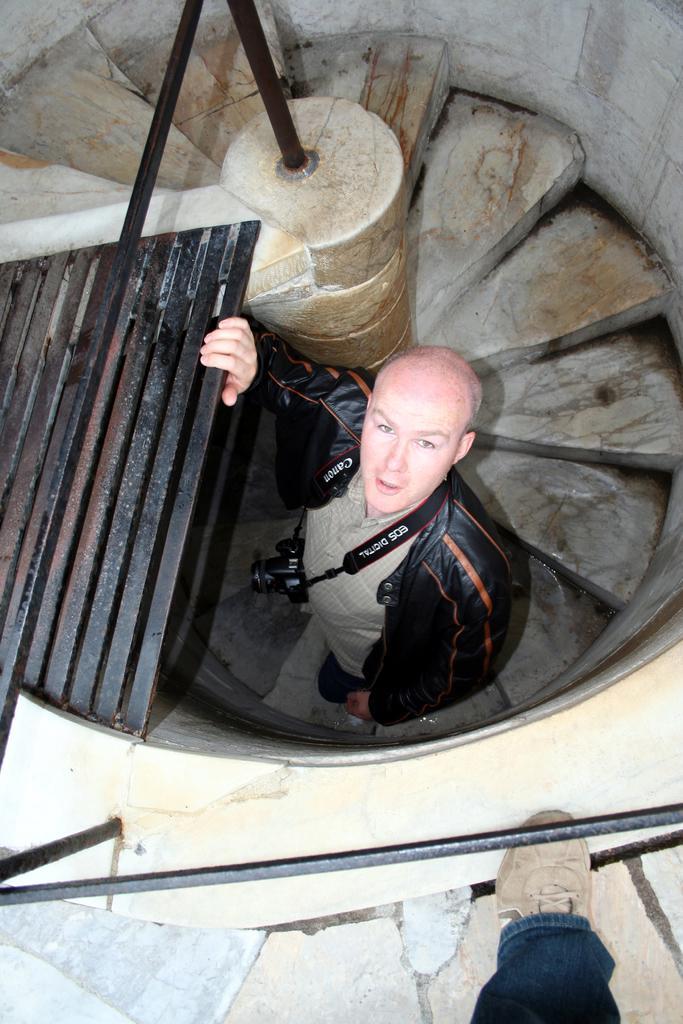In one or two sentences, can you explain what this image depicts? In this picture we can see a person's leg, camera, rods, walls, steps and a man standing. 